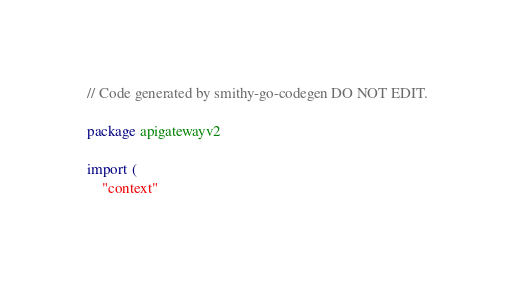Convert code to text. <code><loc_0><loc_0><loc_500><loc_500><_Go_>// Code generated by smithy-go-codegen DO NOT EDIT.

package apigatewayv2

import (
	"context"</code> 